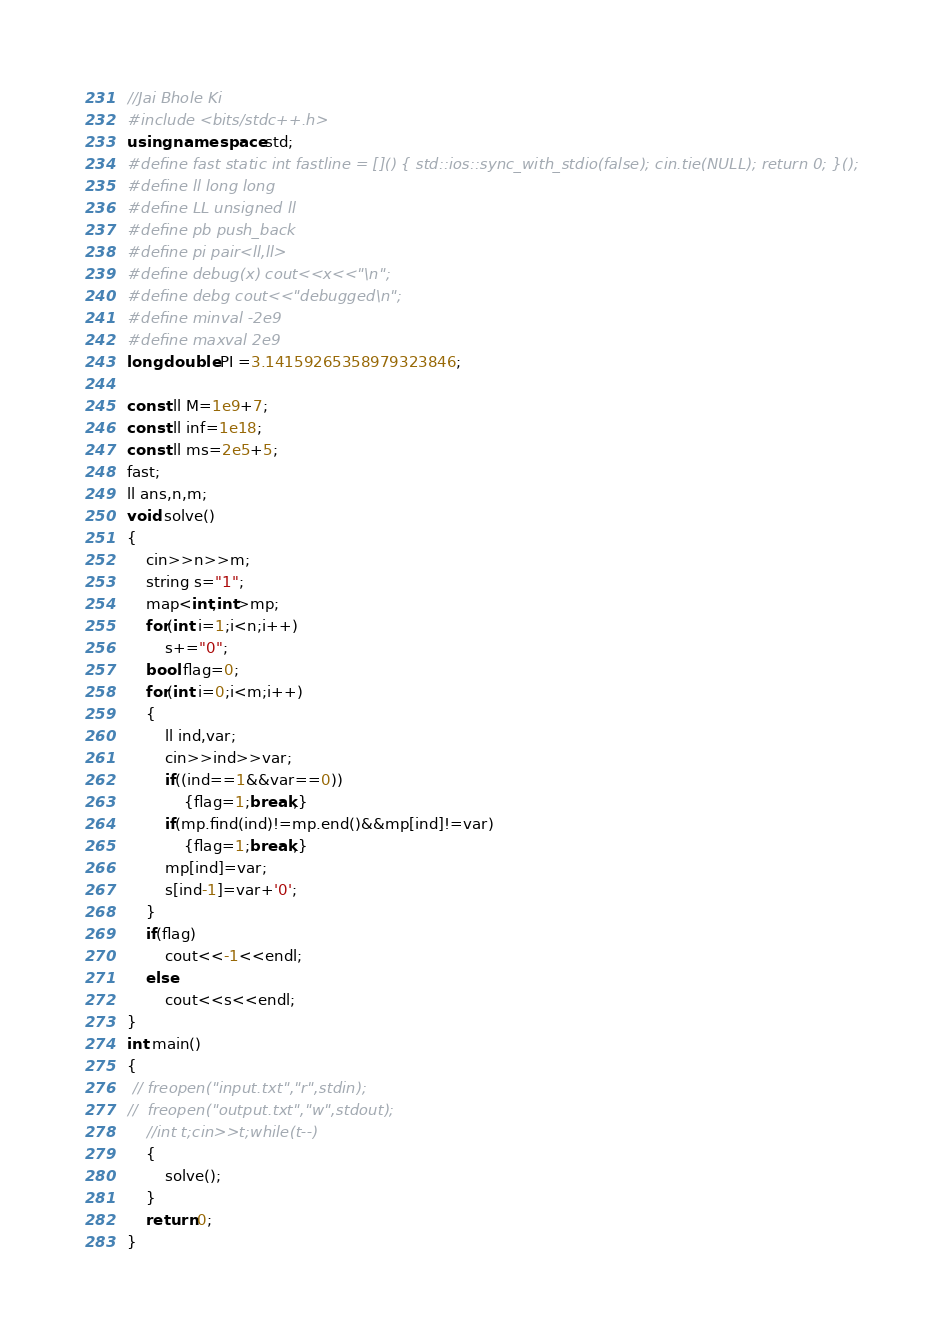<code> <loc_0><loc_0><loc_500><loc_500><_C++_>//Jai Bhole Ki
#include <bits/stdc++.h>
using namespace std;
#define fast static int fastline = []() { std::ios::sync_with_stdio(false); cin.tie(NULL); return 0; }();
#define ll long long
#define LL unsigned ll
#define pb push_back
#define pi pair<ll,ll>
#define debug(x) cout<<x<<"\n";
#define debg cout<<"debugged\n";
#define minval -2e9
#define maxval 2e9
long double PI =3.14159265358979323846;
 
const ll M=1e9+7;
const ll inf=1e18;
const ll ms=2e5+5;
fast;
ll ans,n,m;
void solve()
{
    cin>>n>>m;
    string s="1";
    map<int,int>mp;
    for(int i=1;i<n;i++)
        s+="0";
    bool flag=0;
    for(int i=0;i<m;i++)
    {
        ll ind,var;
        cin>>ind>>var;
        if((ind==1&&var==0))
            {flag=1;break;}
        if(mp.find(ind)!=mp.end()&&mp[ind]!=var)
            {flag=1;break;}
        mp[ind]=var;
        s[ind-1]=var+'0';
    }
    if(flag)
        cout<<-1<<endl;
    else
        cout<<s<<endl;
}
int main()
{
 // freopen("input.txt","r",stdin);
//  freopen("output.txt","w",stdout);
    //int t;cin>>t;while(t--)
    {
        solve();
    }
    return 0;
}</code> 